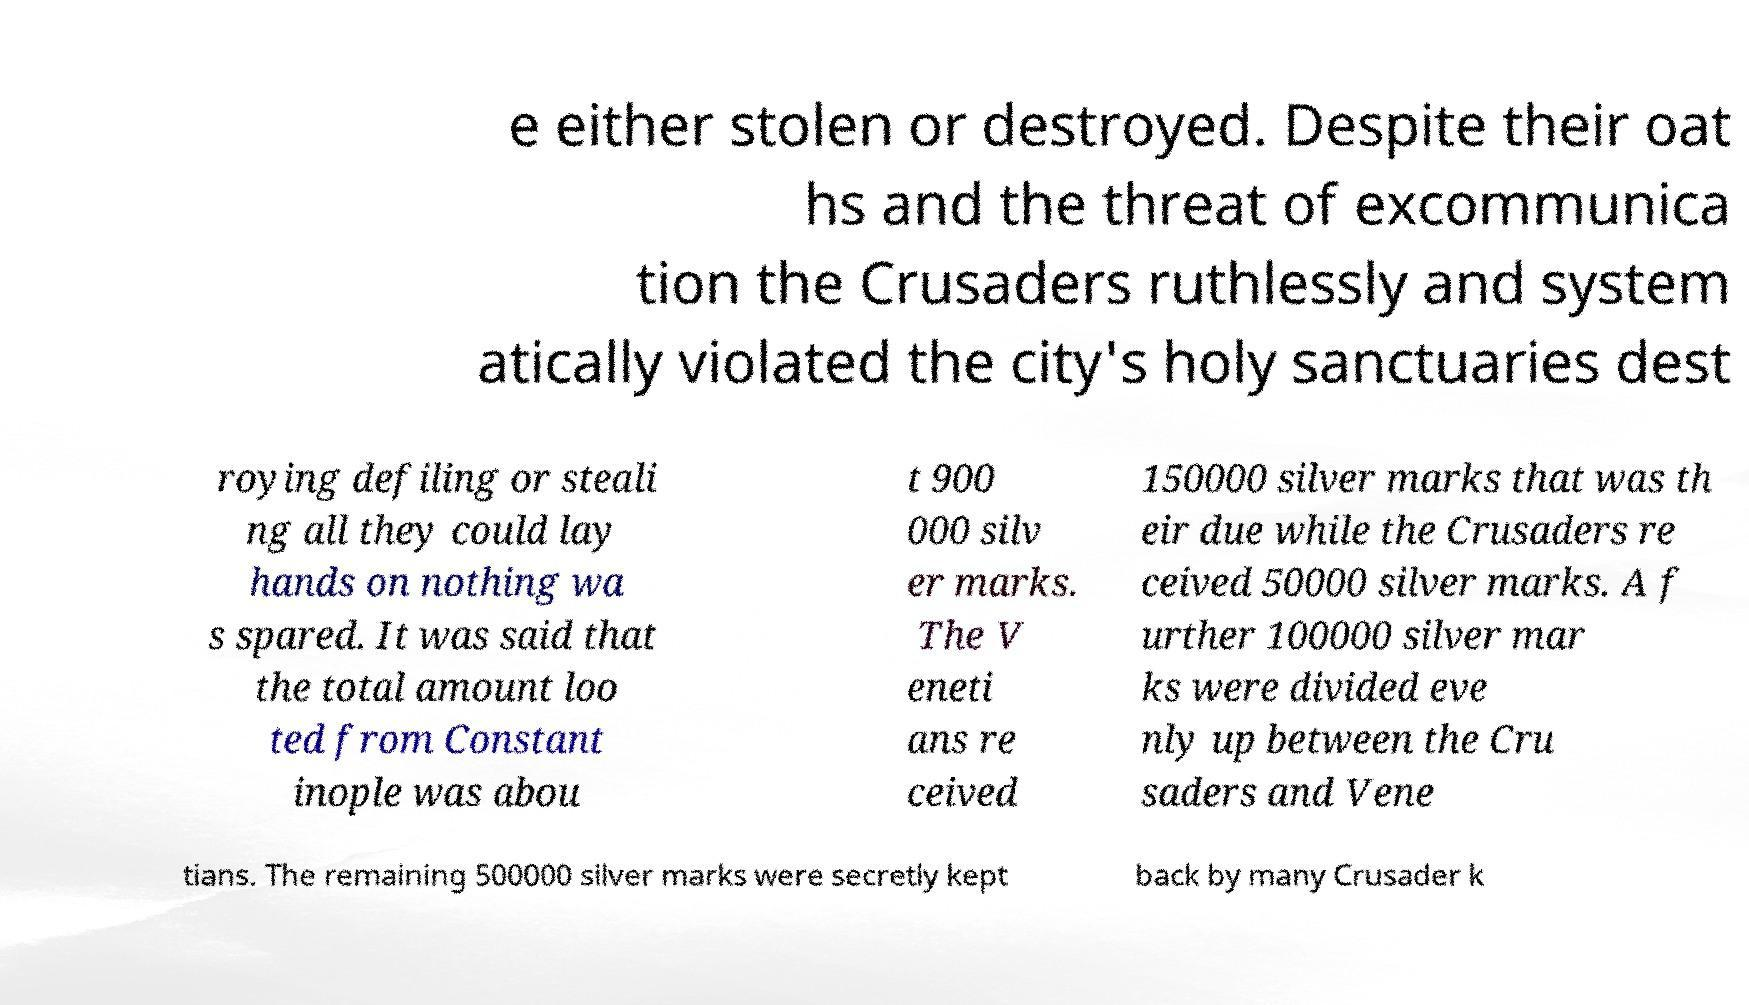Can you read and provide the text displayed in the image?This photo seems to have some interesting text. Can you extract and type it out for me? e either stolen or destroyed. Despite their oat hs and the threat of excommunica tion the Crusaders ruthlessly and system atically violated the city's holy sanctuaries dest roying defiling or steali ng all they could lay hands on nothing wa s spared. It was said that the total amount loo ted from Constant inople was abou t 900 000 silv er marks. The V eneti ans re ceived 150000 silver marks that was th eir due while the Crusaders re ceived 50000 silver marks. A f urther 100000 silver mar ks were divided eve nly up between the Cru saders and Vene tians. The remaining 500000 silver marks were secretly kept back by many Crusader k 